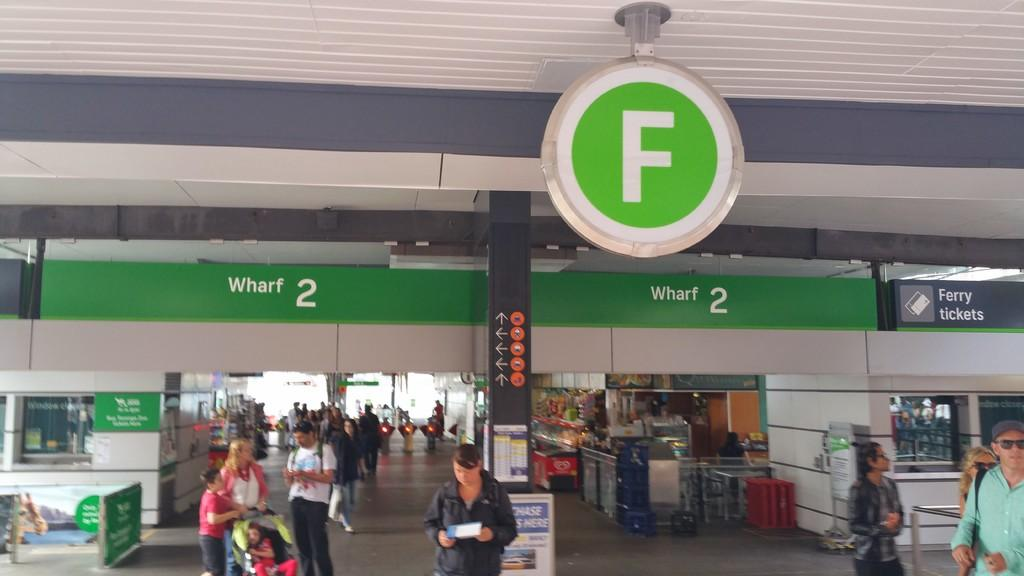<image>
Render a clear and concise summary of the photo. The ferry terminal signs offer ferry tickets to the right. 